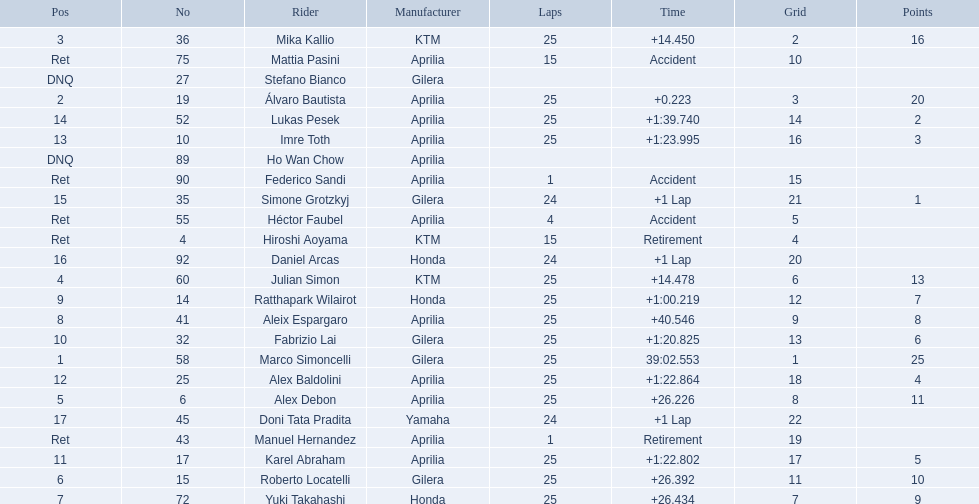Who were all of the riders? Marco Simoncelli, Álvaro Bautista, Mika Kallio, Julian Simon, Alex Debon, Roberto Locatelli, Yuki Takahashi, Aleix Espargaro, Ratthapark Wilairot, Fabrizio Lai, Karel Abraham, Alex Baldolini, Imre Toth, Lukas Pesek, Simone Grotzkyj, Daniel Arcas, Doni Tata Pradita, Hiroshi Aoyama, Mattia Pasini, Héctor Faubel, Federico Sandi, Manuel Hernandez, Stefano Bianco, Ho Wan Chow. How many laps did they complete? 25, 25, 25, 25, 25, 25, 25, 25, 25, 25, 25, 25, 25, 25, 24, 24, 24, 15, 15, 4, 1, 1, , . Between marco simoncelli and hiroshi aoyama, who had more laps? Marco Simoncelli. 